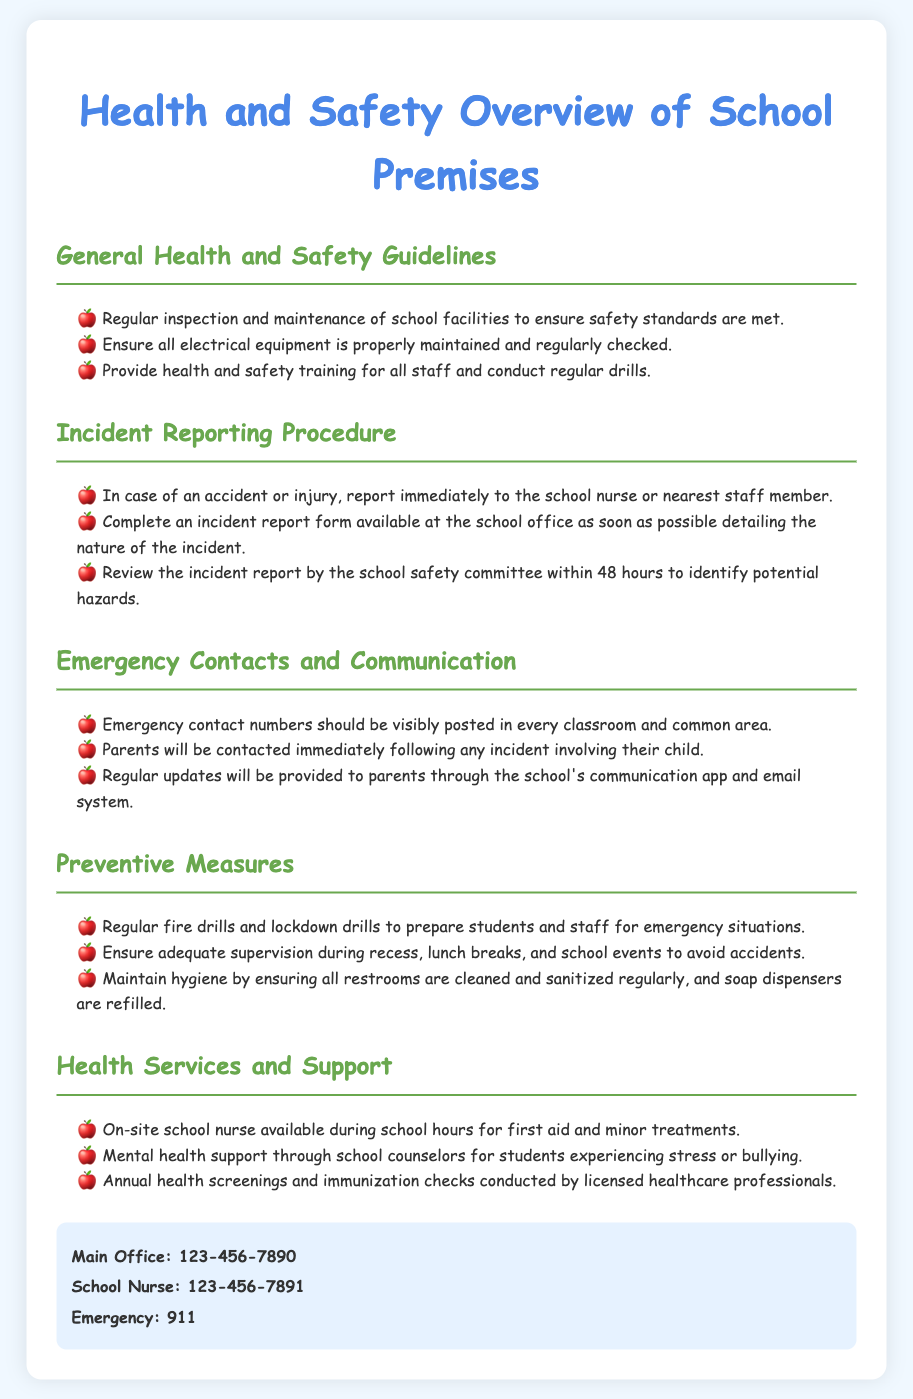What are the general health and safety guidelines? The general health and safety guidelines include regular inspection and maintenance of school facilities, maintaining electrical equipment, and providing health and safety training for staff.
Answer: Regular inspection and maintenance, electrical equipment maintenance, health and safety training Who should be contacted in case of an incident? In case of an accident or injury, the school nurse or the nearest staff member should be contacted.
Answer: School nurse or nearest staff member What is reviewed to identify potential hazards? The incident report is reviewed by the school safety committee to identify potential hazards.
Answer: Incident report What types of drills are conducted regularly? Regular fire drills and lockdown drills are conducted to prepare students and staff for emergencies.
Answer: Fire drills and lockdown drills How often are health screenings conducted? Health screenings and immunization checks are conducted annually by licensed healthcare professionals.
Answer: Annually What phone number is listed for the school nurse? The school nurse's contact number is listed for immediate assistance during school hours.
Answer: 123-456-7891 How quickly will parents be contacted after an incident? Parents will be contacted immediately following any incident involving their child.
Answer: Immediately What is ensured during recess and lunch breaks? Adequate supervision is ensured during recess, lunch breaks, and school events to avoid accidents.
Answer: Adequate supervision 